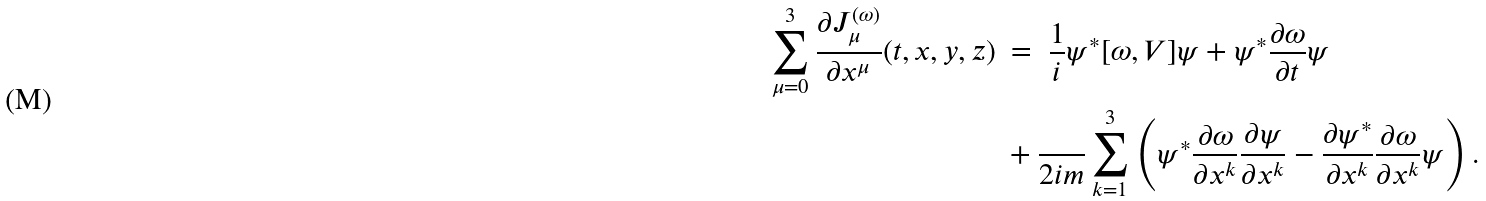Convert formula to latex. <formula><loc_0><loc_0><loc_500><loc_500>\sum _ { \mu = 0 } ^ { 3 } \frac { \partial J _ { \mu } ^ { ( \omega ) } } { \partial x ^ { \mu } } ( t , x , y , z ) \ & = \ \frac { 1 } { i } \psi ^ { \ast } [ \omega , V ] \psi + \psi ^ { \ast } \frac { \partial \omega } { \partial t } \psi \\ & + \frac { } { 2 i m } \sum _ { k = 1 } ^ { 3 } \left ( \psi ^ { \ast } \frac { \partial \omega } { \partial x ^ { k } } \frac { \partial \psi } { \partial x ^ { k } } - \frac { \partial \psi ^ { \ast } } { \partial x ^ { k } } \frac { \partial \omega } { \partial x ^ { k } } \psi \right ) .</formula> 